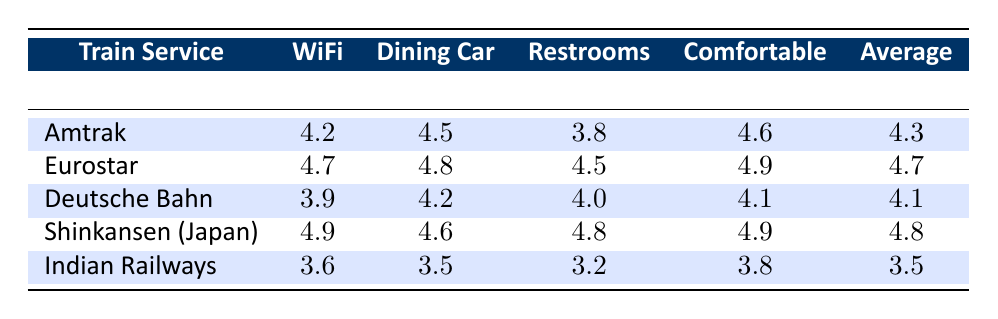What is the satisfaction rating for WiFi on the Eurostar service? The table shows the WiFi satisfaction rating for the Eurostar service as 4.7.
Answer: 4.7 Which train service has the highest comfort seating rating? The table indicates that the Shinkansen (Japan) has the highest rating for Comfortable Seating at 4.9.
Answer: Shinkansen (Japan) What is the average satisfaction rating for Indian Railways? The average can be determined by summing the ratings for Indian Railways: (3.6 + 3.5 + 3.2 + 3.8) = 14.1. There are 4 ratings, so the average is 14.1/4 = 3.525, rounded to 3.5 in the table.
Answer: 3.5 Did Deutsche Bahn receive a higher satisfaction rating for its Restrooms compared to Indian Railways? The Restroom rating for Deutsche Bahn is 4.0 and for Indian Railways, it is 3.2. Since 4.0 is greater than 3.2, the answer is yes.
Answer: Yes Which train service has the best overall average rating? To find this, we calculate the average ratings for each service. Eurostar has an average of 4.7, Shinkansen (Japan) has 4.8, Amtrak is 4.3, Deutsche Bahn is 4.1, and Indian Railways is 3.5. The highest overall average rating is for Shinkansen (Japan) at 4.8.
Answer: Shinkansen (Japan) 